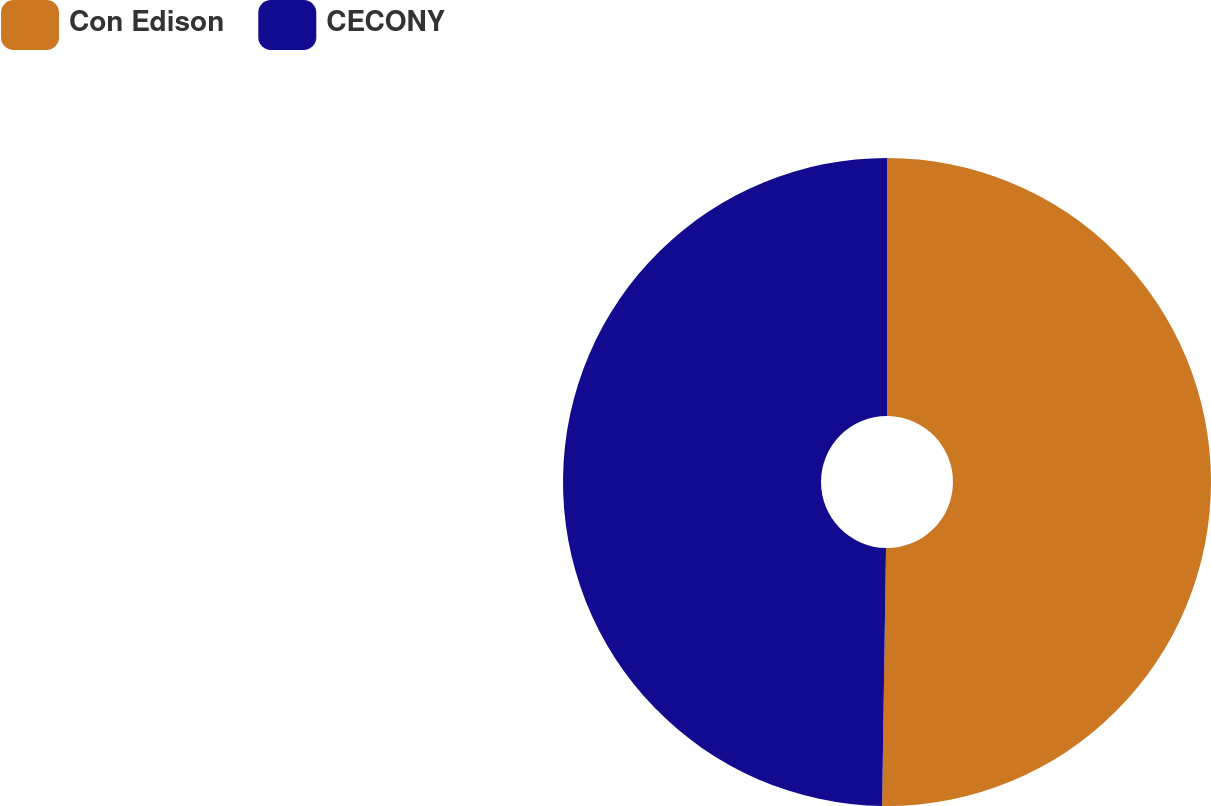Convert chart. <chart><loc_0><loc_0><loc_500><loc_500><pie_chart><fcel>Con Edison<fcel>CECONY<nl><fcel>50.24%<fcel>49.76%<nl></chart> 